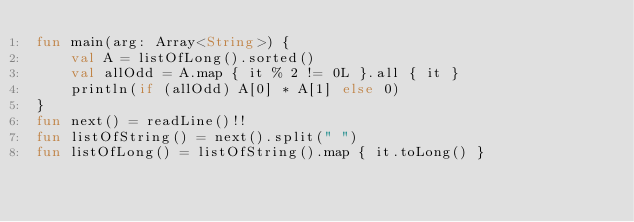Convert code to text. <code><loc_0><loc_0><loc_500><loc_500><_Kotlin_>fun main(arg: Array<String>) {
    val A = listOfLong().sorted()
    val allOdd = A.map { it % 2 != 0L }.all { it }
    println(if (allOdd) A[0] * A[1] else 0)
}
fun next() = readLine()!!
fun listOfString() = next().split(" ")
fun listOfLong() = listOfString().map { it.toLong() }</code> 